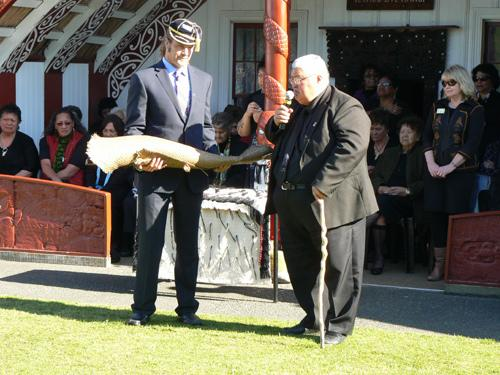What is the thin object the man holding the microphone is using to prop up called?

Choices:
A) cane
B) dagger
C) shovel
D) flute cane 